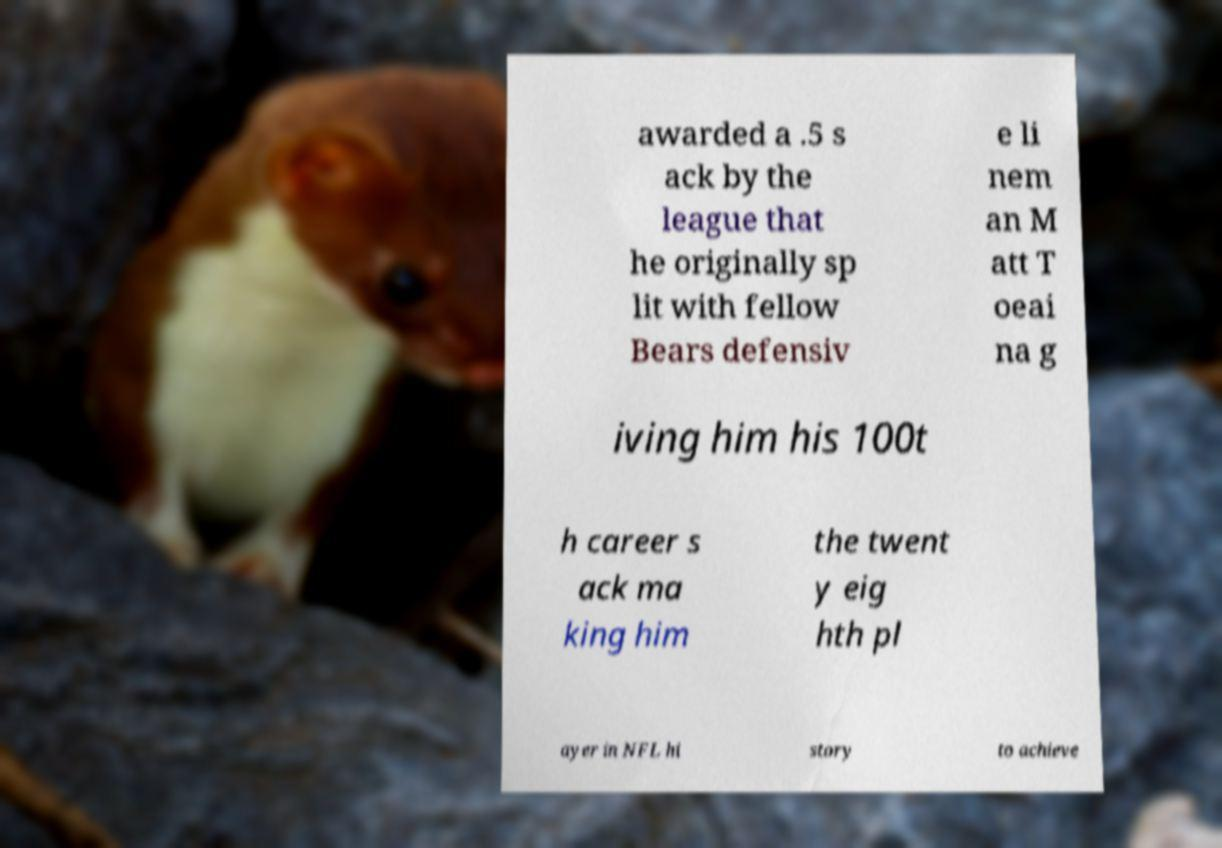For documentation purposes, I need the text within this image transcribed. Could you provide that? awarded a .5 s ack by the league that he originally sp lit with fellow Bears defensiv e li nem an M att T oeai na g iving him his 100t h career s ack ma king him the twent y eig hth pl ayer in NFL hi story to achieve 